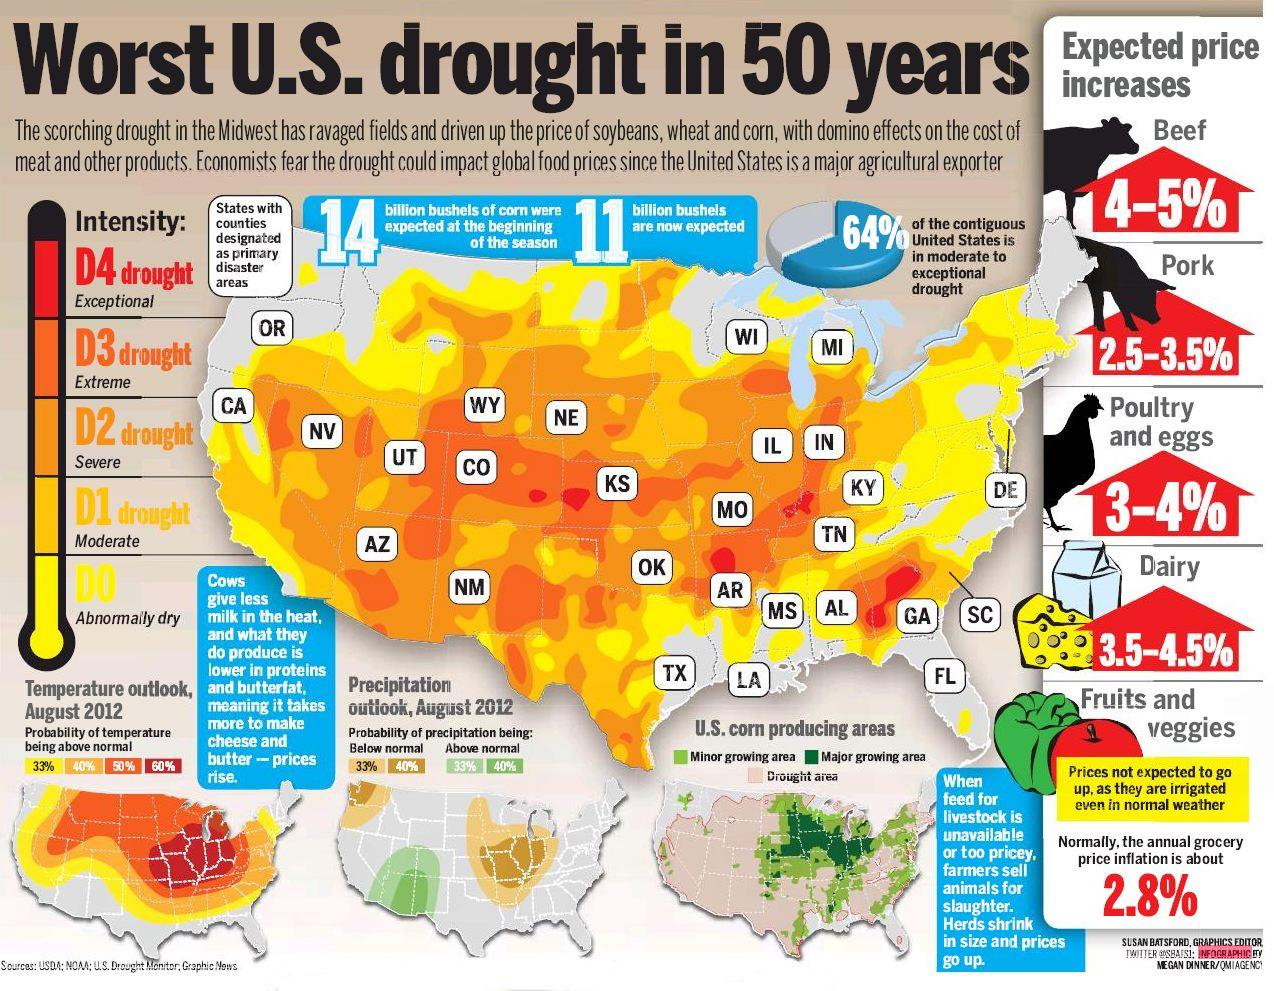List a handful of essential elements in this visual. It is predicted that beef will experience a significant increase in price compared to pork. The intensity of drought in Florida is currently classified as abnormally dry. The western part of America is severely affected by the drought and is unable to produce corn at a significant level. It is predicted that the prices of poultry and eggs, as well as dairy products, are likely to increase significantly in the near future. The state of Georgia in the southern region of the United States is currently experiencing a severe drought condition, classified as exceptional intensity. 